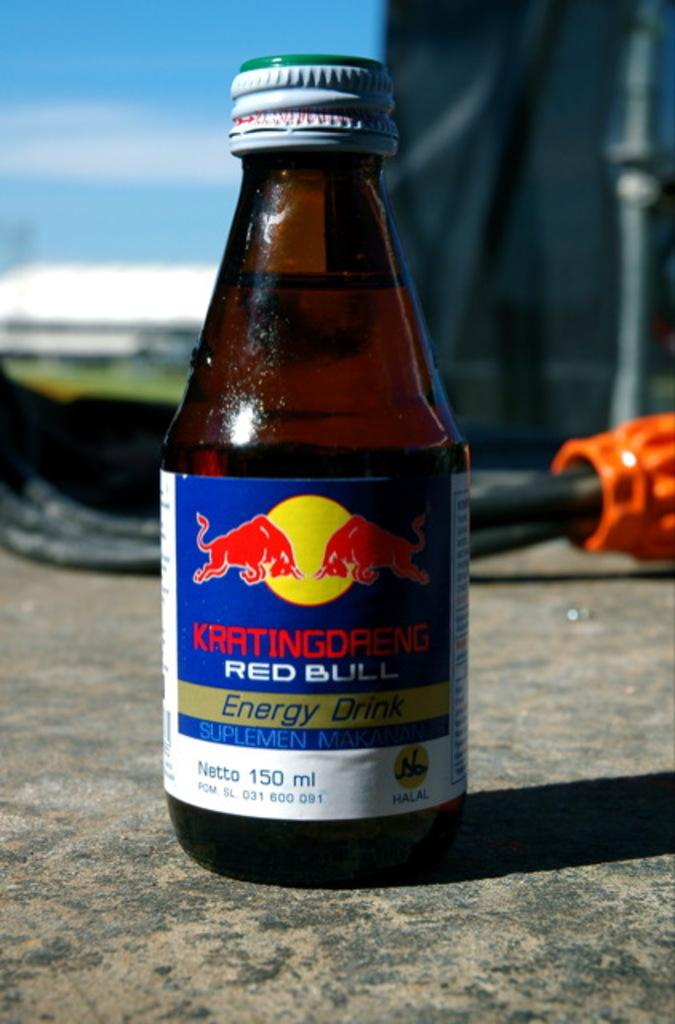<image>
Render a clear and concise summary of the photo. A little glass bottle of Red Bull Energy Drink placed on the ground outside. 